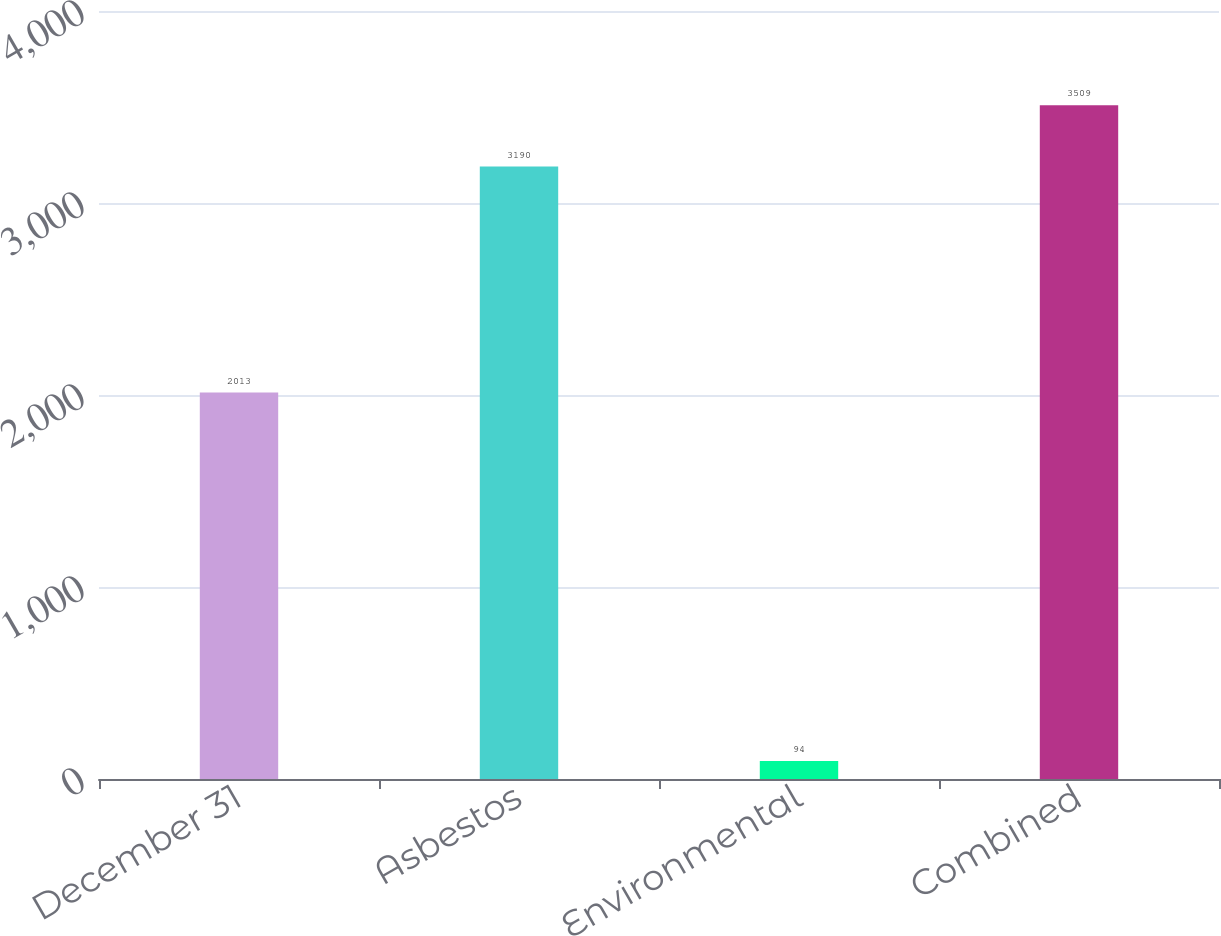Convert chart to OTSL. <chart><loc_0><loc_0><loc_500><loc_500><bar_chart><fcel>December 31<fcel>Asbestos<fcel>Environmental<fcel>Combined<nl><fcel>2013<fcel>3190<fcel>94<fcel>3509<nl></chart> 